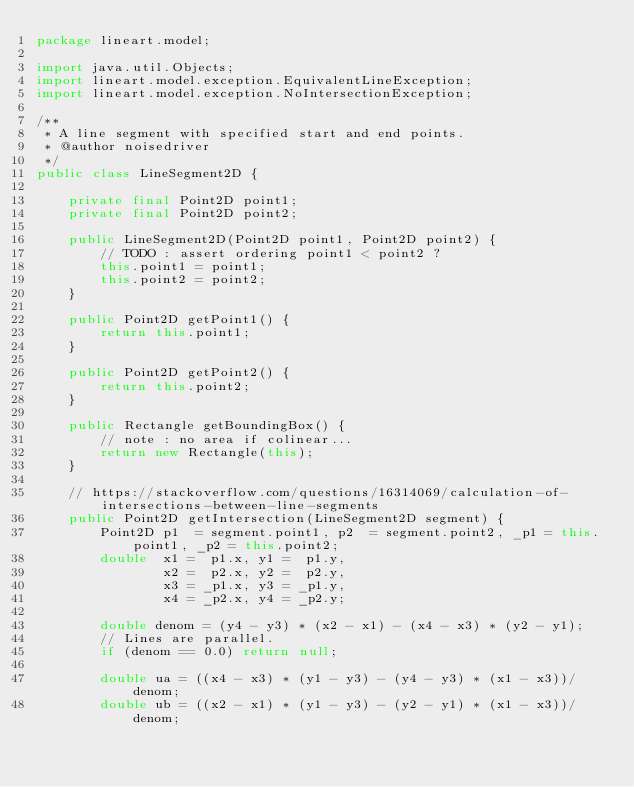Convert code to text. <code><loc_0><loc_0><loc_500><loc_500><_Java_>package lineart.model;

import java.util.Objects;
import lineart.model.exception.EquivalentLineException;
import lineart.model.exception.NoIntersectionException;

/**
 * A line segment with specified start and end points.
 * @author noisedriver
 */
public class LineSegment2D {
    
    private final Point2D point1;
    private final Point2D point2;
    
    public LineSegment2D(Point2D point1, Point2D point2) {
        // TODO : assert ordering point1 < point2 ?
        this.point1 = point1;
        this.point2 = point2;
    }
    
    public Point2D getPoint1() {
        return this.point1;
    }
    
    public Point2D getPoint2() {
        return this.point2;
    }
    
    public Rectangle getBoundingBox() {
        // note : no area if colinear...
        return new Rectangle(this);
    }
    
    // https://stackoverflow.com/questions/16314069/calculation-of-intersections-between-line-segments
    public Point2D getIntersection(LineSegment2D segment) {
        Point2D p1  = segment.point1, p2  = segment.point2, _p1 = this.point1, _p2 = this.point2;
        double  x1 =  p1.x, y1 =  p1.y,
                x2 =  p2.x, y2 =  p2.y,
                x3 = _p1.x, y3 = _p1.y,
                x4 = _p2.x, y4 = _p2.y;
        
        double denom = (y4 - y3) * (x2 - x1) - (x4 - x3) * (y2 - y1);
        // Lines are parallel.
        if (denom == 0.0) return null;
        
        double ua = ((x4 - x3) * (y1 - y3) - (y4 - y3) * (x1 - x3))/denom;
        double ub = ((x2 - x1) * (y1 - y3) - (y2 - y1) * (x1 - x3))/denom;</code> 